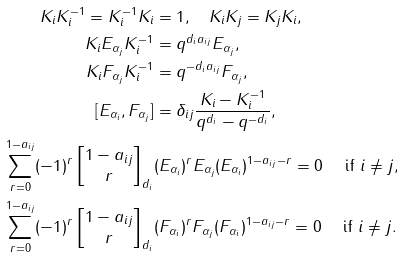<formula> <loc_0><loc_0><loc_500><loc_500>K _ { i } K _ { i } ^ { - 1 } = K _ { i } ^ { - 1 } K _ { i } & = 1 , \quad K _ { i } K _ { j } = K _ { j } K _ { i } , \\ K _ { i } E _ { \alpha _ { j } } K _ { i } ^ { - 1 } & = q ^ { d _ { i } a _ { i j } } E _ { \alpha _ { j } } , \\ K _ { i } F _ { \alpha _ { j } } K _ { i } ^ { - 1 } & = q ^ { - d _ { i } a _ { i j } } F _ { \alpha _ { j } } , \\ [ E _ { \alpha _ { i } } , F _ { \alpha _ { j } } ] & = \delta _ { i j } \frac { K _ { i } - K _ { i } ^ { - 1 } } { q ^ { d _ { i } } - q ^ { - d _ { i } } } , \\ \sum _ { r = 0 } ^ { 1 - a _ { i j } } ( - 1 ) ^ { r } \left [ \begin{matrix} 1 - a _ { i j } \\ r \end{matrix} \right ] _ { d _ { i } } & ( E _ { \alpha _ { i } } ) ^ { r } E _ { \alpha _ { j } } ( E _ { \alpha _ { i } } ) ^ { 1 - a _ { i j } - r } = 0 \ \quad \text {if $i\ne j$} , \\ \sum _ { r = 0 } ^ { 1 - a _ { i j } } ( - 1 ) ^ { r } \left [ \begin{matrix} 1 - a _ { i j } \\ r \end{matrix} \right ] _ { d _ { i } } & ( F _ { \alpha _ { i } } ) ^ { r } F _ { \alpha _ { j } } ( F _ { \alpha _ { i } } ) ^ { 1 - a _ { i j } - r } = 0 \ \quad \text {if $i\ne j$} .</formula> 